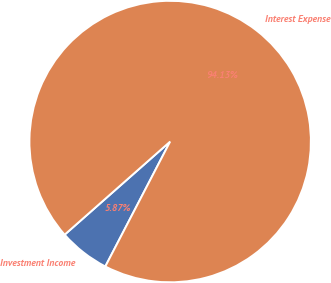<chart> <loc_0><loc_0><loc_500><loc_500><pie_chart><fcel>Investment Income<fcel>Interest Expense<nl><fcel>5.87%<fcel>94.13%<nl></chart> 